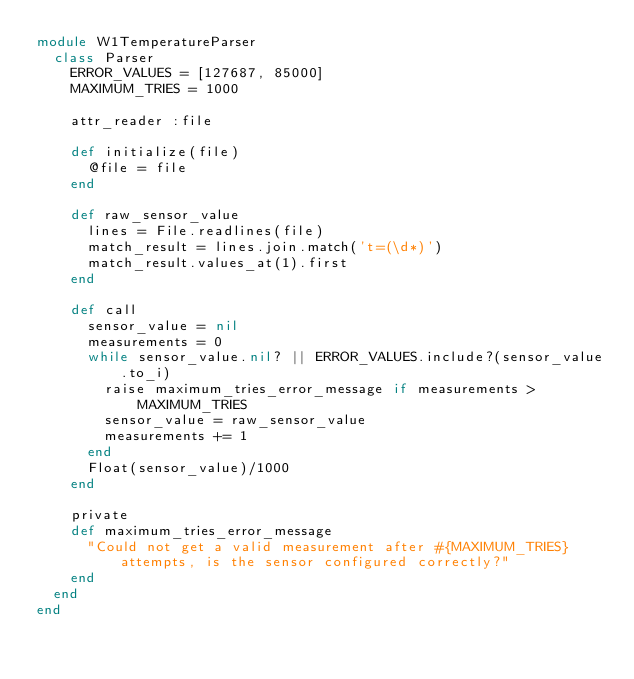<code> <loc_0><loc_0><loc_500><loc_500><_Ruby_>module W1TemperatureParser
  class Parser
    ERROR_VALUES = [127687, 85000]
    MAXIMUM_TRIES = 1000

    attr_reader :file

    def initialize(file)
      @file = file
    end

    def raw_sensor_value
      lines = File.readlines(file)
      match_result = lines.join.match('t=(\d*)')
      match_result.values_at(1).first
    end

    def call
      sensor_value = nil
      measurements = 0
      while sensor_value.nil? || ERROR_VALUES.include?(sensor_value.to_i)
        raise maximum_tries_error_message if measurements > MAXIMUM_TRIES
        sensor_value = raw_sensor_value
        measurements += 1
      end
      Float(sensor_value)/1000
    end

    private
    def maximum_tries_error_message
      "Could not get a valid measurement after #{MAXIMUM_TRIES} attempts, is the sensor configured correctly?"
    end
  end
end

</code> 